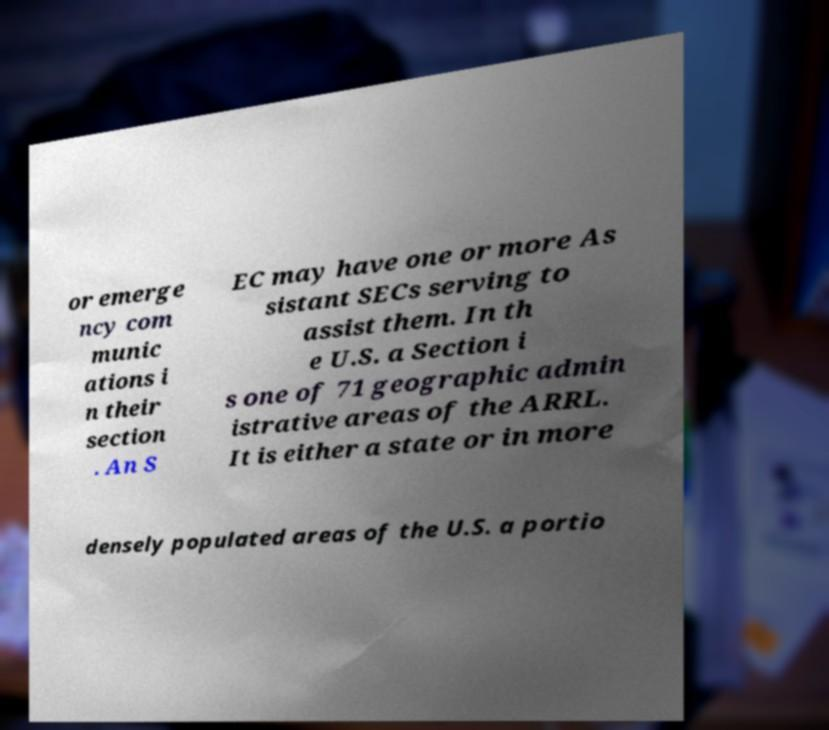Could you assist in decoding the text presented in this image and type it out clearly? or emerge ncy com munic ations i n their section . An S EC may have one or more As sistant SECs serving to assist them. In th e U.S. a Section i s one of 71 geographic admin istrative areas of the ARRL. It is either a state or in more densely populated areas of the U.S. a portio 